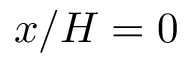Convert formula to latex. <formula><loc_0><loc_0><loc_500><loc_500>x / H = 0</formula> 